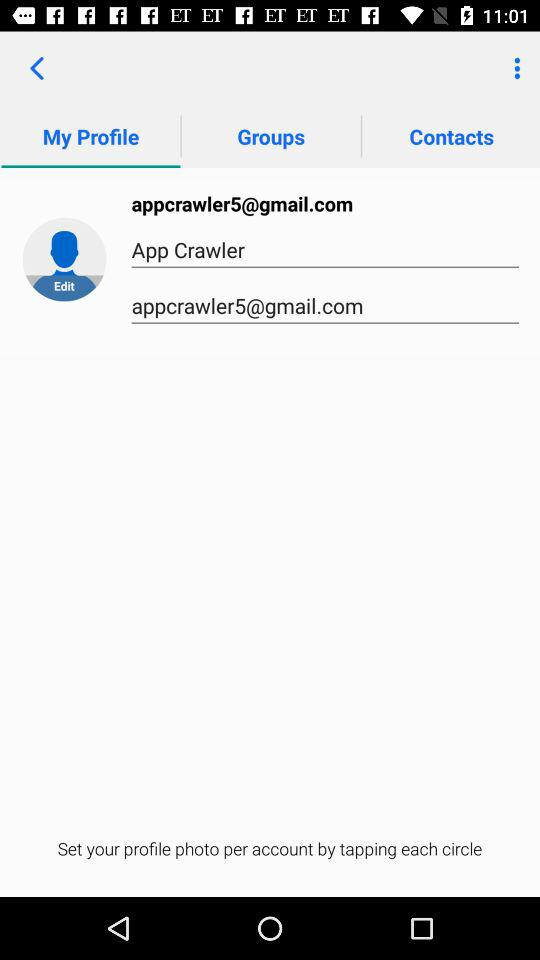Which tab has been selected? The selected tab is "My Profile". 